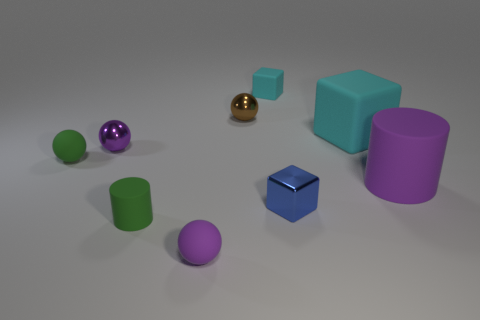Subtract all brown spheres. How many spheres are left? 3 Subtract all green cylinders. How many cylinders are left? 1 Subtract all cylinders. How many objects are left? 7 Subtract all blue cubes. How many green cylinders are left? 1 Add 1 large purple matte cylinders. How many large purple matte cylinders are left? 2 Add 8 brown balls. How many brown balls exist? 9 Subtract 1 green cylinders. How many objects are left? 8 Subtract 2 balls. How many balls are left? 2 Subtract all yellow cylinders. Subtract all blue blocks. How many cylinders are left? 2 Subtract all small green balls. Subtract all rubber cylinders. How many objects are left? 6 